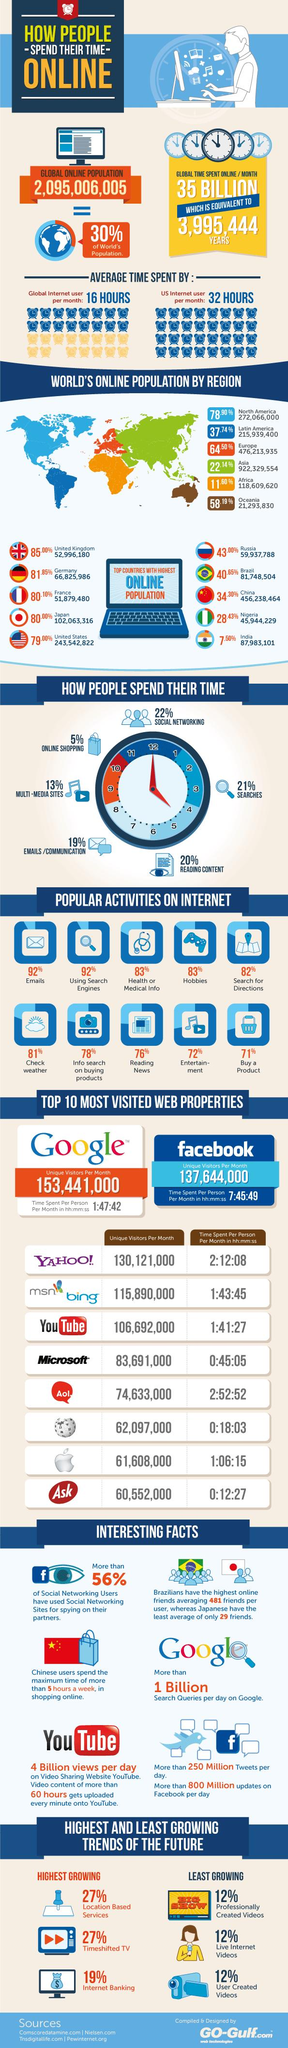Mention a couple of crucial points in this snapshot. Oceania is the continent with the least online population in the world. The number of unique visitors to YouTube per month is 106,692,000. As of 2021, the online population of India is approximately 87,983,101 people. According to a recent study, it was found that 83% of people worldwide use the internet to obtain health information. The continent with the largest online population in the world is Asia. 